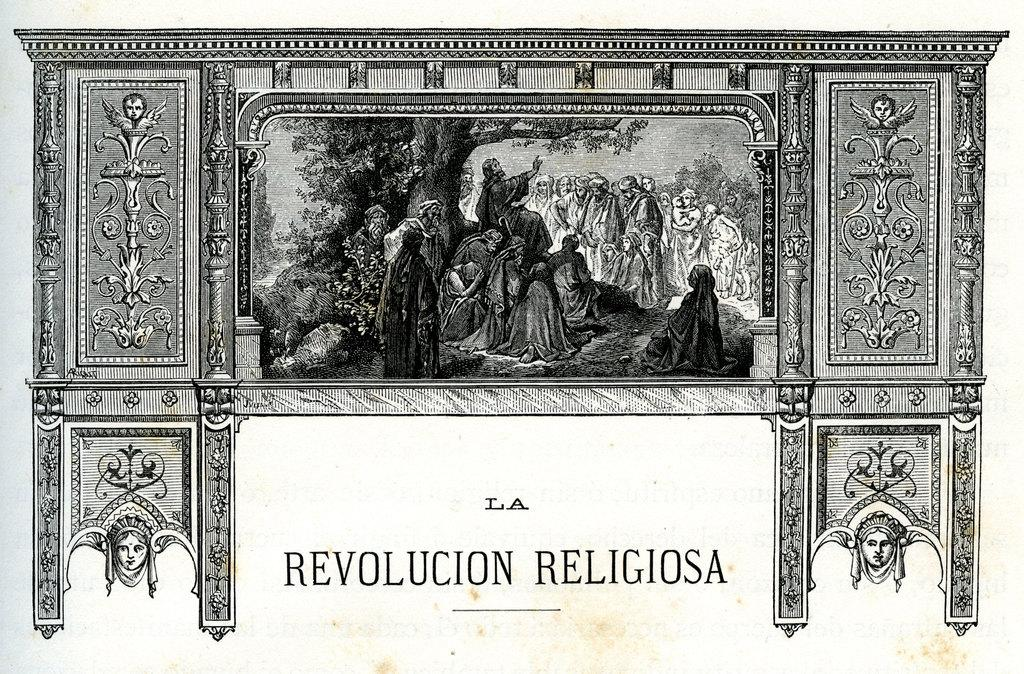What is the color scheme of the image? The image is black and white. How many people are present in the image? There are many people in the image. What type of natural elements can be seen in the image? There are trees in the image. Can you describe the borders of the image? The image has borders with designs, and there are faces in the design of the borders. Can you see a stranger's toe in the design of the borders? There is no stranger or toe present in the image, as it is a black and white image with people, trees, and designed borders. 